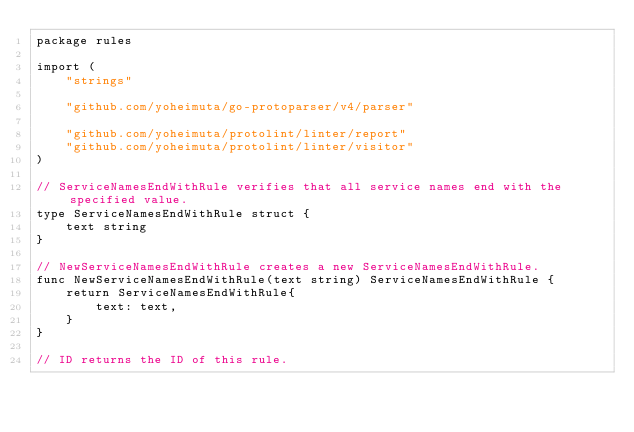<code> <loc_0><loc_0><loc_500><loc_500><_Go_>package rules

import (
	"strings"

	"github.com/yoheimuta/go-protoparser/v4/parser"

	"github.com/yoheimuta/protolint/linter/report"
	"github.com/yoheimuta/protolint/linter/visitor"
)

// ServiceNamesEndWithRule verifies that all service names end with the specified value.
type ServiceNamesEndWithRule struct {
	text string
}

// NewServiceNamesEndWithRule creates a new ServiceNamesEndWithRule.
func NewServiceNamesEndWithRule(text string) ServiceNamesEndWithRule {
	return ServiceNamesEndWithRule{
		text: text,
	}
}

// ID returns the ID of this rule.</code> 